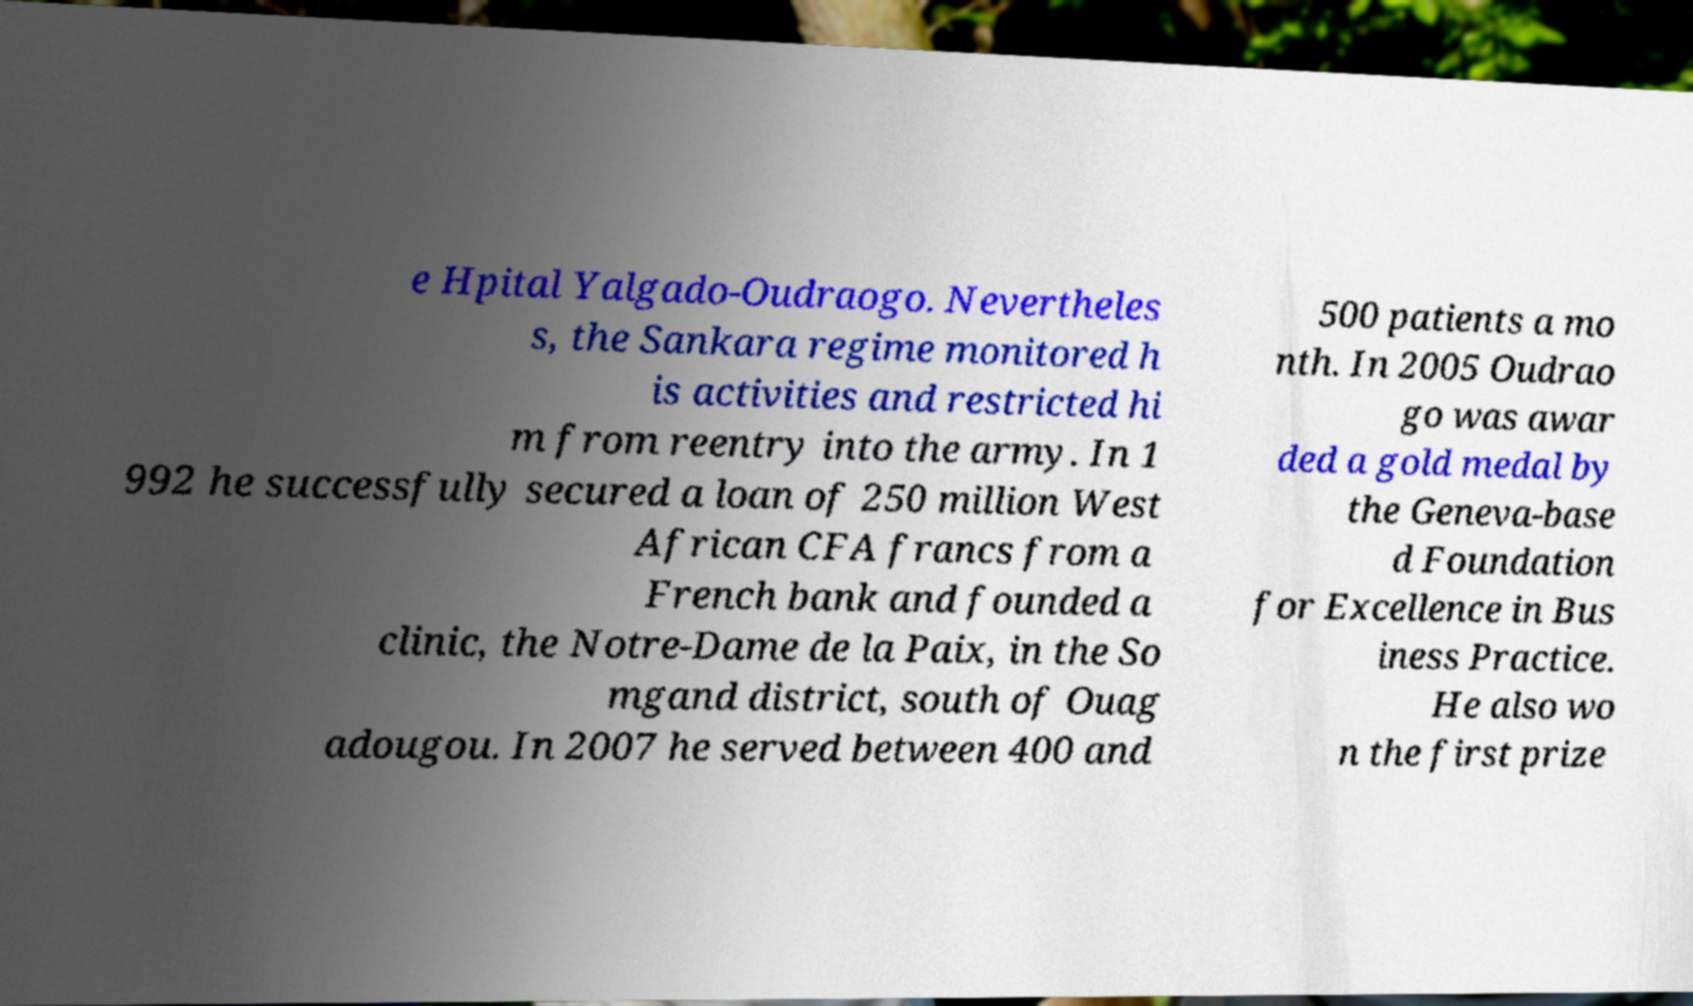What messages or text are displayed in this image? I need them in a readable, typed format. e Hpital Yalgado-Oudraogo. Nevertheles s, the Sankara regime monitored h is activities and restricted hi m from reentry into the army. In 1 992 he successfully secured a loan of 250 million West African CFA francs from a French bank and founded a clinic, the Notre-Dame de la Paix, in the So mgand district, south of Ouag adougou. In 2007 he served between 400 and 500 patients a mo nth. In 2005 Oudrao go was awar ded a gold medal by the Geneva-base d Foundation for Excellence in Bus iness Practice. He also wo n the first prize 